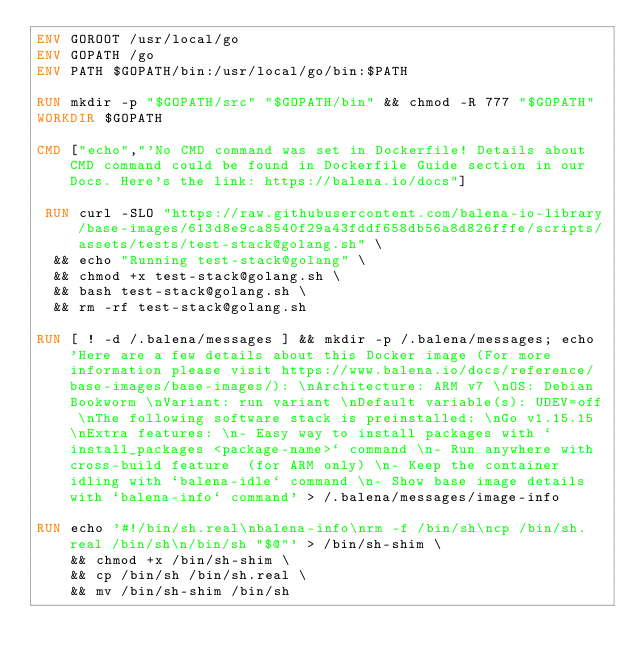Convert code to text. <code><loc_0><loc_0><loc_500><loc_500><_Dockerfile_>ENV GOROOT /usr/local/go
ENV GOPATH /go
ENV PATH $GOPATH/bin:/usr/local/go/bin:$PATH

RUN mkdir -p "$GOPATH/src" "$GOPATH/bin" && chmod -R 777 "$GOPATH"
WORKDIR $GOPATH

CMD ["echo","'No CMD command was set in Dockerfile! Details about CMD command could be found in Dockerfile Guide section in our Docs. Here's the link: https://balena.io/docs"]

 RUN curl -SLO "https://raw.githubusercontent.com/balena-io-library/base-images/613d8e9ca8540f29a43fddf658db56a8d826fffe/scripts/assets/tests/test-stack@golang.sh" \
  && echo "Running test-stack@golang" \
  && chmod +x test-stack@golang.sh \
  && bash test-stack@golang.sh \
  && rm -rf test-stack@golang.sh 

RUN [ ! -d /.balena/messages ] && mkdir -p /.balena/messages; echo 'Here are a few details about this Docker image (For more information please visit https://www.balena.io/docs/reference/base-images/base-images/): \nArchitecture: ARM v7 \nOS: Debian Bookworm \nVariant: run variant \nDefault variable(s): UDEV=off \nThe following software stack is preinstalled: \nGo v1.15.15 \nExtra features: \n- Easy way to install packages with `install_packages <package-name>` command \n- Run anywhere with cross-build feature  (for ARM only) \n- Keep the container idling with `balena-idle` command \n- Show base image details with `balena-info` command' > /.balena/messages/image-info

RUN echo '#!/bin/sh.real\nbalena-info\nrm -f /bin/sh\ncp /bin/sh.real /bin/sh\n/bin/sh "$@"' > /bin/sh-shim \
	&& chmod +x /bin/sh-shim \
	&& cp /bin/sh /bin/sh.real \
	&& mv /bin/sh-shim /bin/sh</code> 